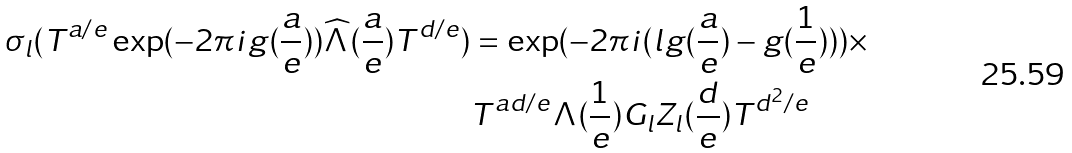<formula> <loc_0><loc_0><loc_500><loc_500>\sigma _ { l } ( T ^ { a / e } \exp ( - 2 \pi i g ( \frac { a } { e } ) ) \widehat { \Lambda } ( \frac { a } { e } ) T ^ { d / e } ) & = \exp ( - 2 \pi i ( l g ( \frac { a } { e } ) - g ( \frac { 1 } { e } ) ) ) \times \\ & T ^ { a d / e } \Lambda ( \frac { 1 } { e } ) G _ { l } Z _ { l } ( \frac { d } { e } ) T ^ { d ^ { 2 } / e }</formula> 